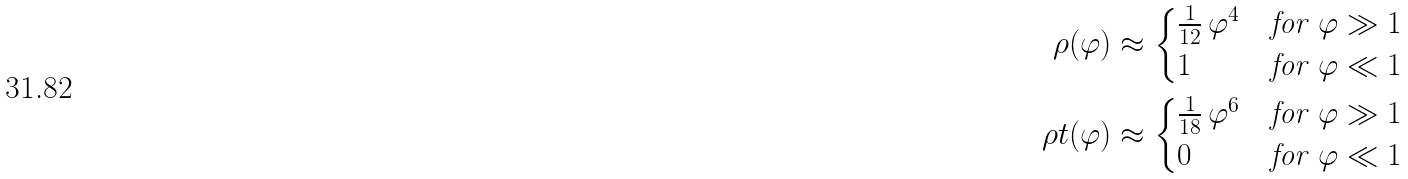Convert formula to latex. <formula><loc_0><loc_0><loc_500><loc_500>\rho ( \varphi ) & \approx \begin{cases} \frac { 1 } { 1 2 } \, \varphi ^ { 4 } & \text {for } \varphi \gg 1 \\ 1 & \text {for } \varphi \ll 1 \end{cases} \\ \rho t ( \varphi ) & \approx \begin{cases} \frac { 1 } { 1 8 } \, \varphi ^ { 6 } & \text {for } \varphi \gg 1 \\ 0 & \text {for } \varphi \ll 1 \end{cases}</formula> 